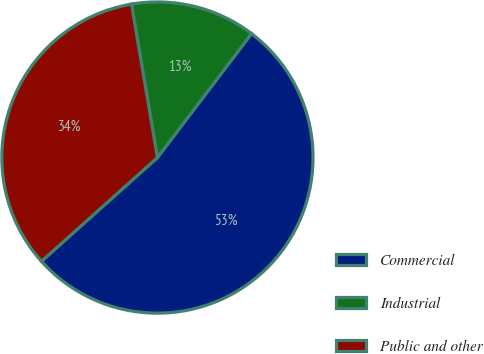<chart> <loc_0><loc_0><loc_500><loc_500><pie_chart><fcel>Commercial<fcel>Industrial<fcel>Public and other<nl><fcel>53.05%<fcel>13.0%<fcel>33.95%<nl></chart> 